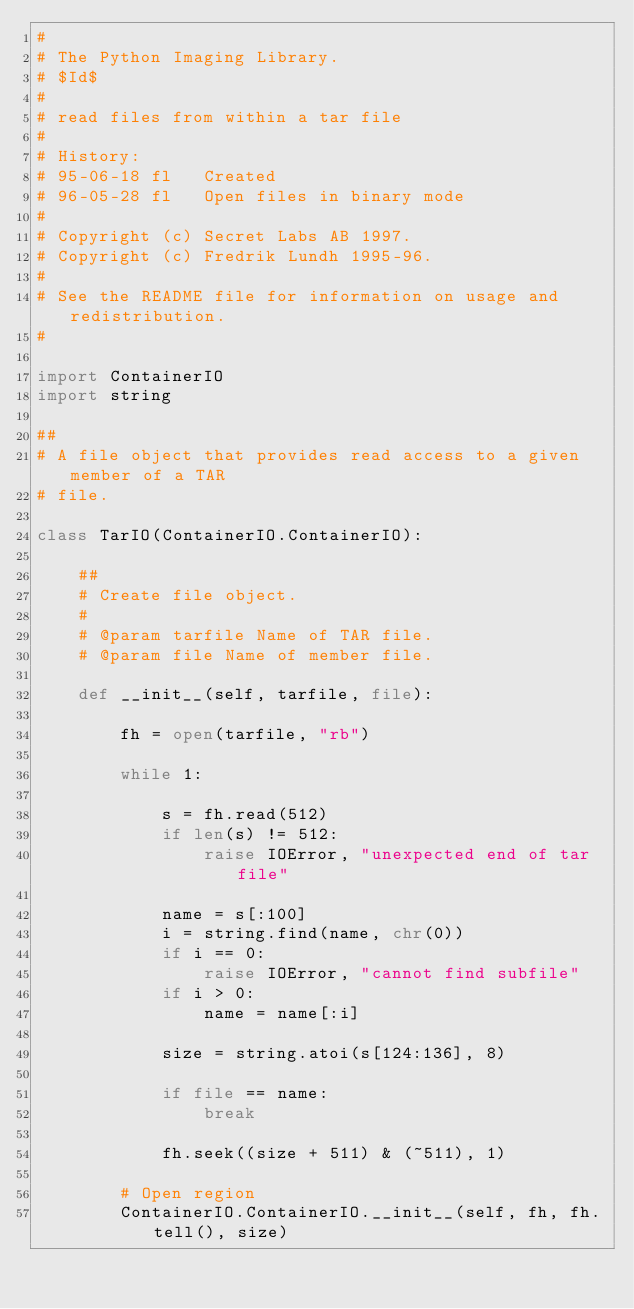Convert code to text. <code><loc_0><loc_0><loc_500><loc_500><_Python_>#
# The Python Imaging Library.
# $Id$
#
# read files from within a tar file
#
# History:
# 95-06-18 fl   Created
# 96-05-28 fl   Open files in binary mode
#
# Copyright (c) Secret Labs AB 1997.
# Copyright (c) Fredrik Lundh 1995-96.
#
# See the README file for information on usage and redistribution.
#

import ContainerIO
import string

##
# A file object that provides read access to a given member of a TAR
# file.

class TarIO(ContainerIO.ContainerIO):

    ##
    # Create file object.
    #
    # @param tarfile Name of TAR file.
    # @param file Name of member file.

    def __init__(self, tarfile, file):

        fh = open(tarfile, "rb")

        while 1:

            s = fh.read(512)
            if len(s) != 512:
                raise IOError, "unexpected end of tar file"

            name = s[:100]
            i = string.find(name, chr(0))
            if i == 0:
                raise IOError, "cannot find subfile"
            if i > 0:
                name = name[:i]

            size = string.atoi(s[124:136], 8)

            if file == name:
                break

            fh.seek((size + 511) & (~511), 1)

        # Open region
        ContainerIO.ContainerIO.__init__(self, fh, fh.tell(), size)
</code> 